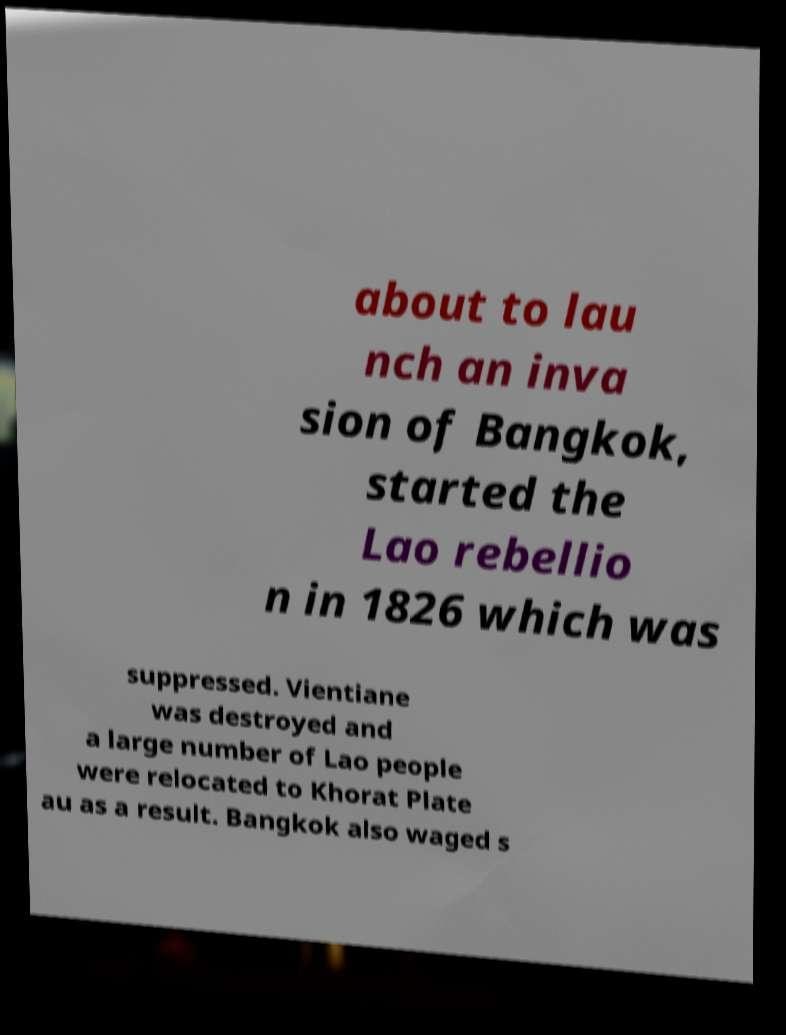Please identify and transcribe the text found in this image. about to lau nch an inva sion of Bangkok, started the Lao rebellio n in 1826 which was suppressed. Vientiane was destroyed and a large number of Lao people were relocated to Khorat Plate au as a result. Bangkok also waged s 